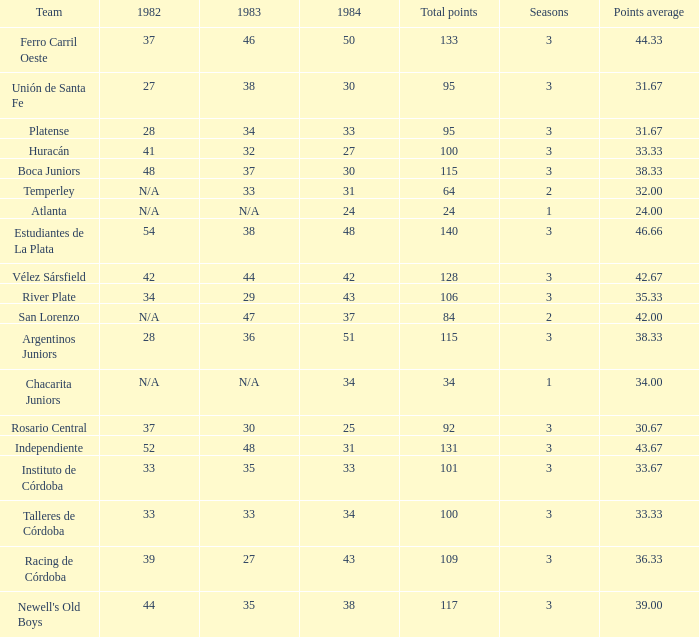What is the total for 1984 for the team with 100 points total and more than 3 seasons? None. 